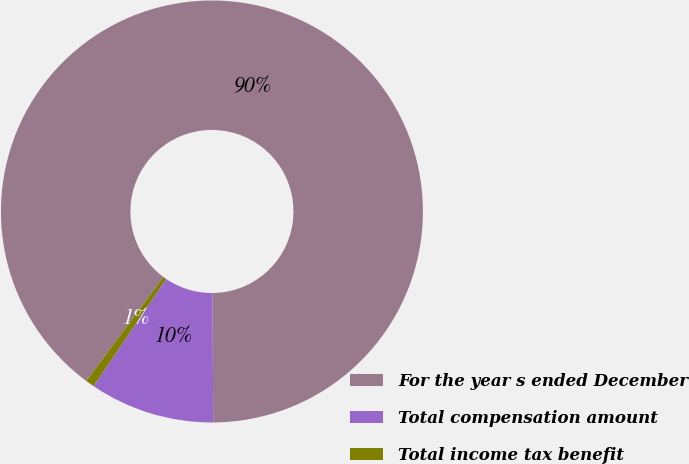Convert chart to OTSL. <chart><loc_0><loc_0><loc_500><loc_500><pie_chart><fcel>For the year s ended December<fcel>Total compensation amount<fcel>Total income tax benefit<nl><fcel>89.75%<fcel>9.58%<fcel>0.67%<nl></chart> 